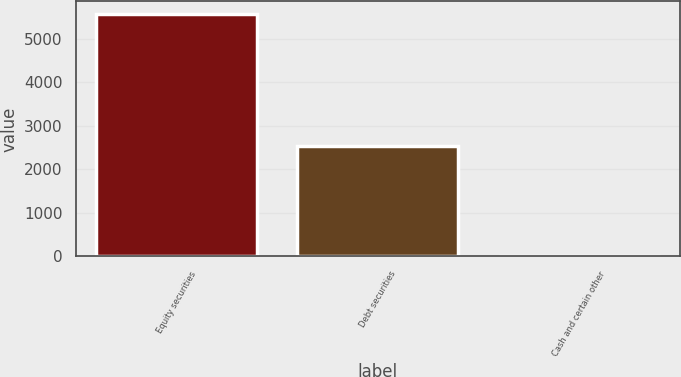Convert chart to OTSL. <chart><loc_0><loc_0><loc_500><loc_500><bar_chart><fcel>Equity securities<fcel>Debt securities<fcel>Cash and certain other<nl><fcel>5575<fcel>2545<fcel>5<nl></chart> 